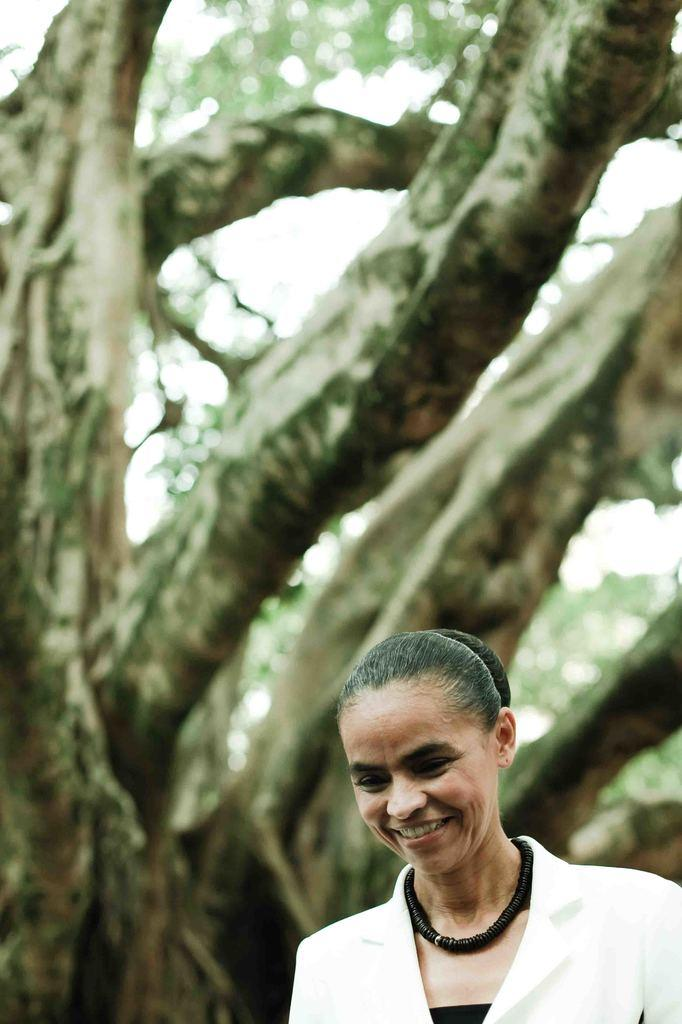Who is present in the image? There is a woman in the image. What can be seen behind the woman? There is a tree behind the woman in the image. Is there any blood visible on the woman in the image? No, there is no blood visible on the woman in the image. Does the tree in the image have any branches? The provided facts do not mention any branches on the tree, so we cannot definitively answer that question. 